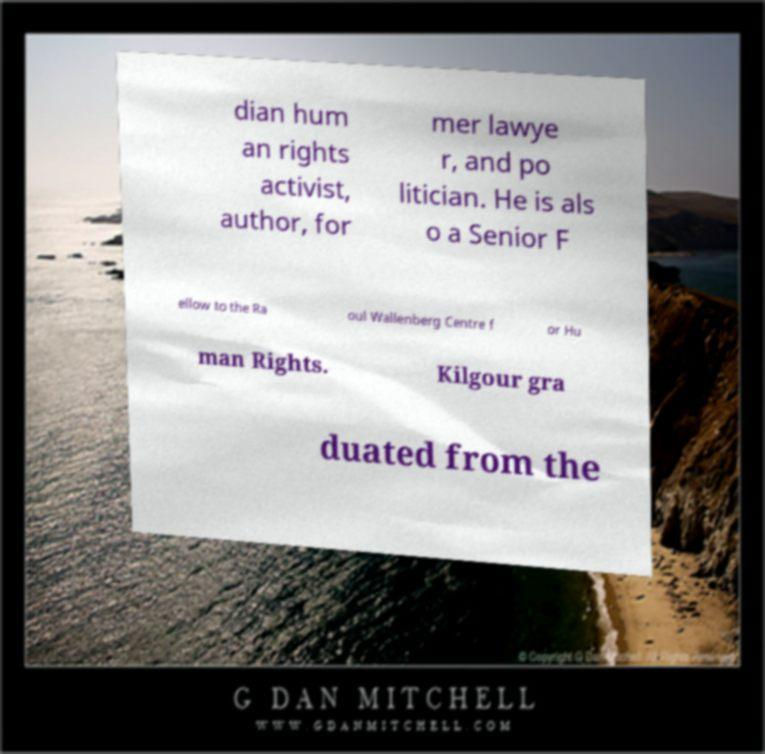Could you extract and type out the text from this image? dian hum an rights activist, author, for mer lawye r, and po litician. He is als o a Senior F ellow to the Ra oul Wallenberg Centre f or Hu man Rights. Kilgour gra duated from the 